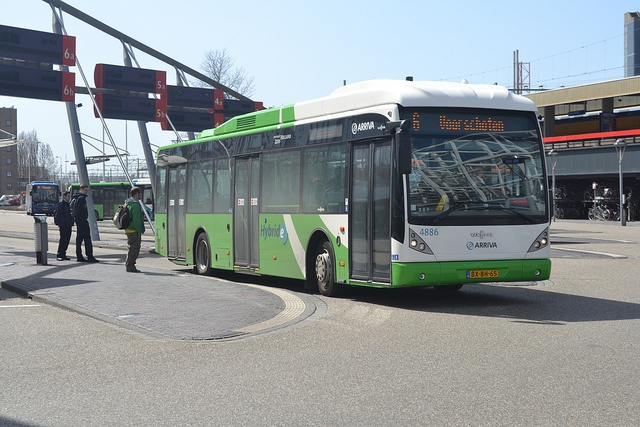Describe the objects in this image and their specific colors. I can see bus in white, gray, black, and darkgray tones, bus in white, black, teal, and purple tones, people in white, black, darkgreen, gray, and teal tones, people in white, black, gray, and darkgray tones, and bus in white, black, gray, navy, and darkblue tones in this image. 